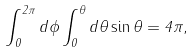<formula> <loc_0><loc_0><loc_500><loc_500>\int _ { 0 } ^ { 2 \pi } d \phi \int _ { 0 } ^ { \theta } d \theta \sin \theta = 4 \pi ,</formula> 